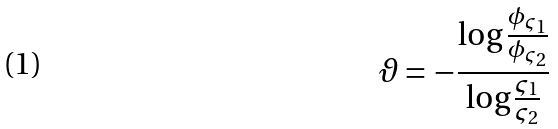Convert formula to latex. <formula><loc_0><loc_0><loc_500><loc_500>\vartheta = - \frac { \log \frac { \phi _ { \varsigma _ { 1 } } } { \phi _ { \varsigma _ { 2 } } } } { \log \frac { \varsigma _ { 1 } } { \varsigma _ { 2 } } }</formula> 